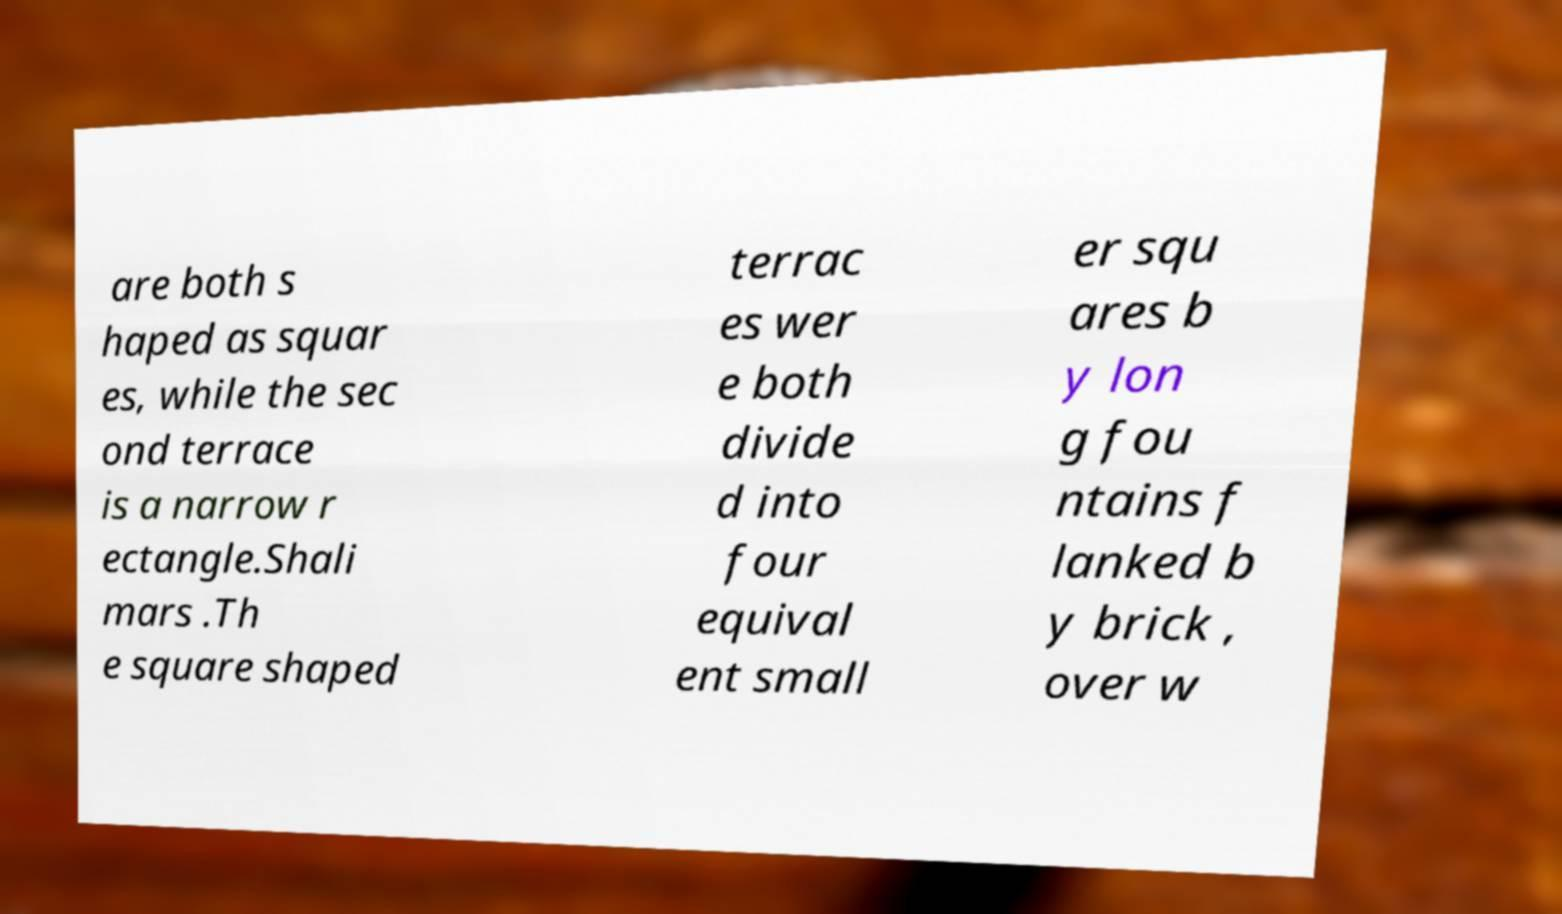Please read and relay the text visible in this image. What does it say? are both s haped as squar es, while the sec ond terrace is a narrow r ectangle.Shali mars .Th e square shaped terrac es wer e both divide d into four equival ent small er squ ares b y lon g fou ntains f lanked b y brick , over w 